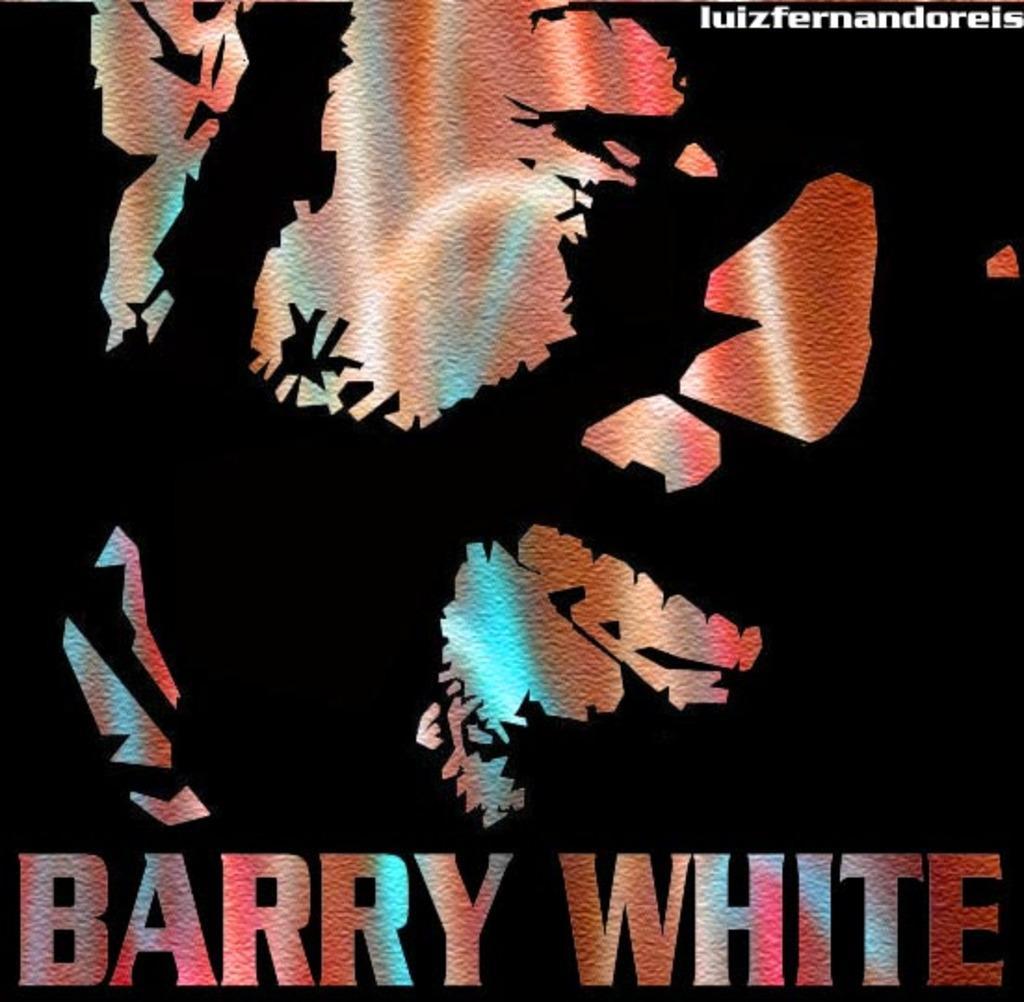Could you give a brief overview of what you see in this image? This is a graphic poster. At the bottom of it, we see "BARRY WHITE" written on it. 